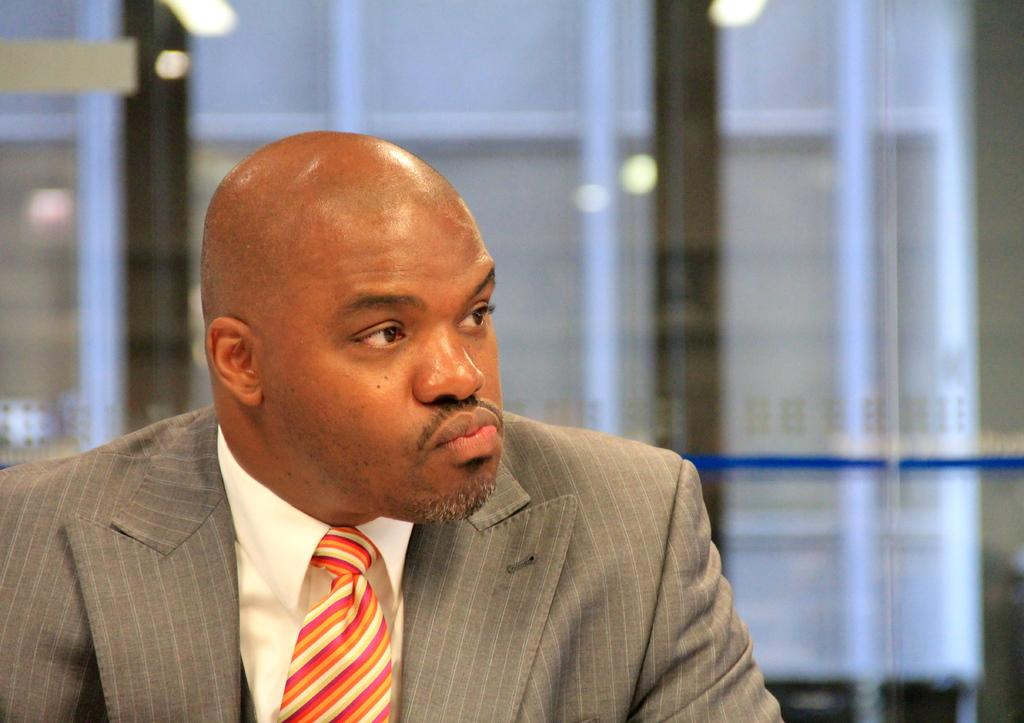What is the main subject of the image? There is a man in the image. Can you describe the man's appearance? The man has a bald head. What can be observed about the background in the image? The background behind the man is blurry. Can you see any ghosts interacting with the man in the image? There are no ghosts present in the image. What type of quiver is the man holding in the image? The man is not holding any quiver in the image. 